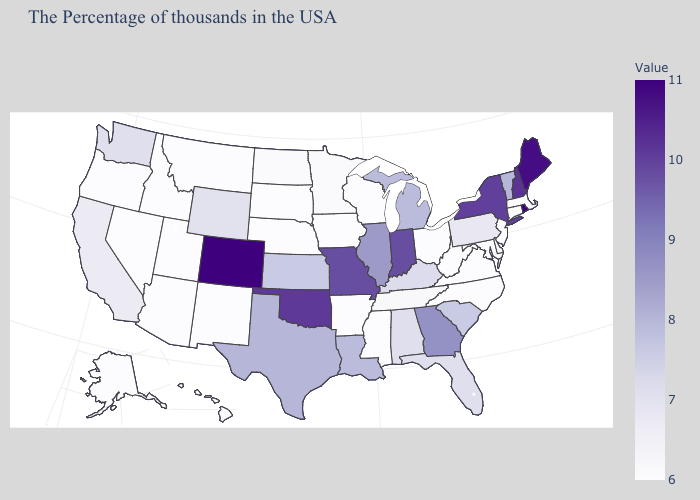Does Rhode Island have the highest value in the USA?
Give a very brief answer. Yes. Does Connecticut have the lowest value in the USA?
Short answer required. Yes. Which states hav the highest value in the West?
Answer briefly. Colorado. 